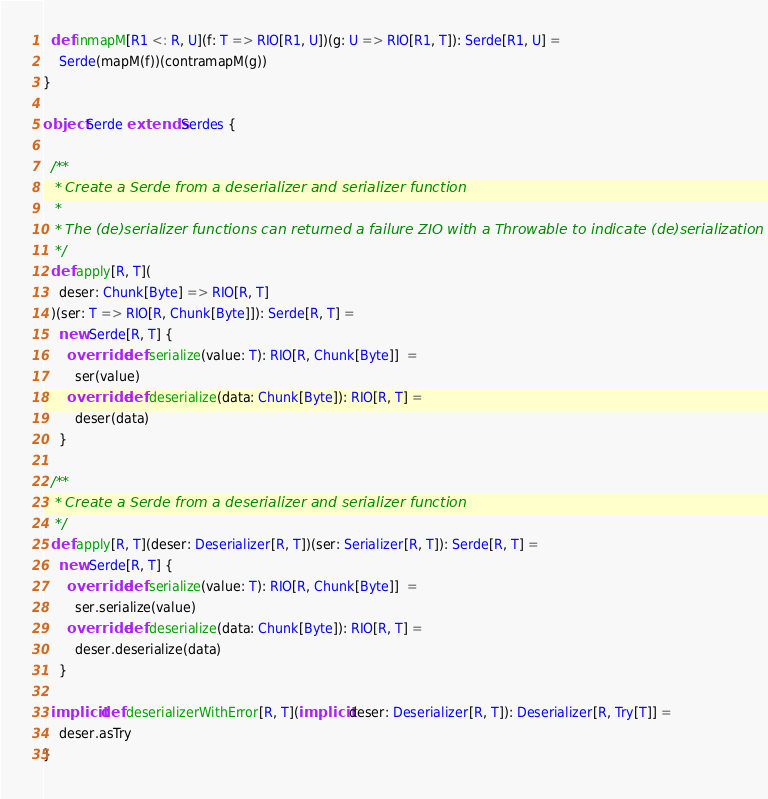<code> <loc_0><loc_0><loc_500><loc_500><_Scala_>  def inmapM[R1 <: R, U](f: T => RIO[R1, U])(g: U => RIO[R1, T]): Serde[R1, U] =
    Serde(mapM(f))(contramapM(g))
}

object Serde extends Serdes {

  /**
   * Create a Serde from a deserializer and serializer function
   *
   * The (de)serializer functions can returned a failure ZIO with a Throwable to indicate (de)serialization failure
   */
  def apply[R, T](
    deser: Chunk[Byte] => RIO[R, T]
  )(ser: T => RIO[R, Chunk[Byte]]): Serde[R, T] =
    new Serde[R, T] {
      override def serialize(value: T): RIO[R, Chunk[Byte]]  =
        ser(value)
      override def deserialize(data: Chunk[Byte]): RIO[R, T] =
        deser(data)
    }

  /**
   * Create a Serde from a deserializer and serializer function
   */
  def apply[R, T](deser: Deserializer[R, T])(ser: Serializer[R, T]): Serde[R, T] =
    new Serde[R, T] {
      override def serialize(value: T): RIO[R, Chunk[Byte]]  =
        ser.serialize(value)
      override def deserialize(data: Chunk[Byte]): RIO[R, T] =
        deser.deserialize(data)
    }

  implicit def deserializerWithError[R, T](implicit deser: Deserializer[R, T]): Deserializer[R, Try[T]] =
    deser.asTry
}
</code> 